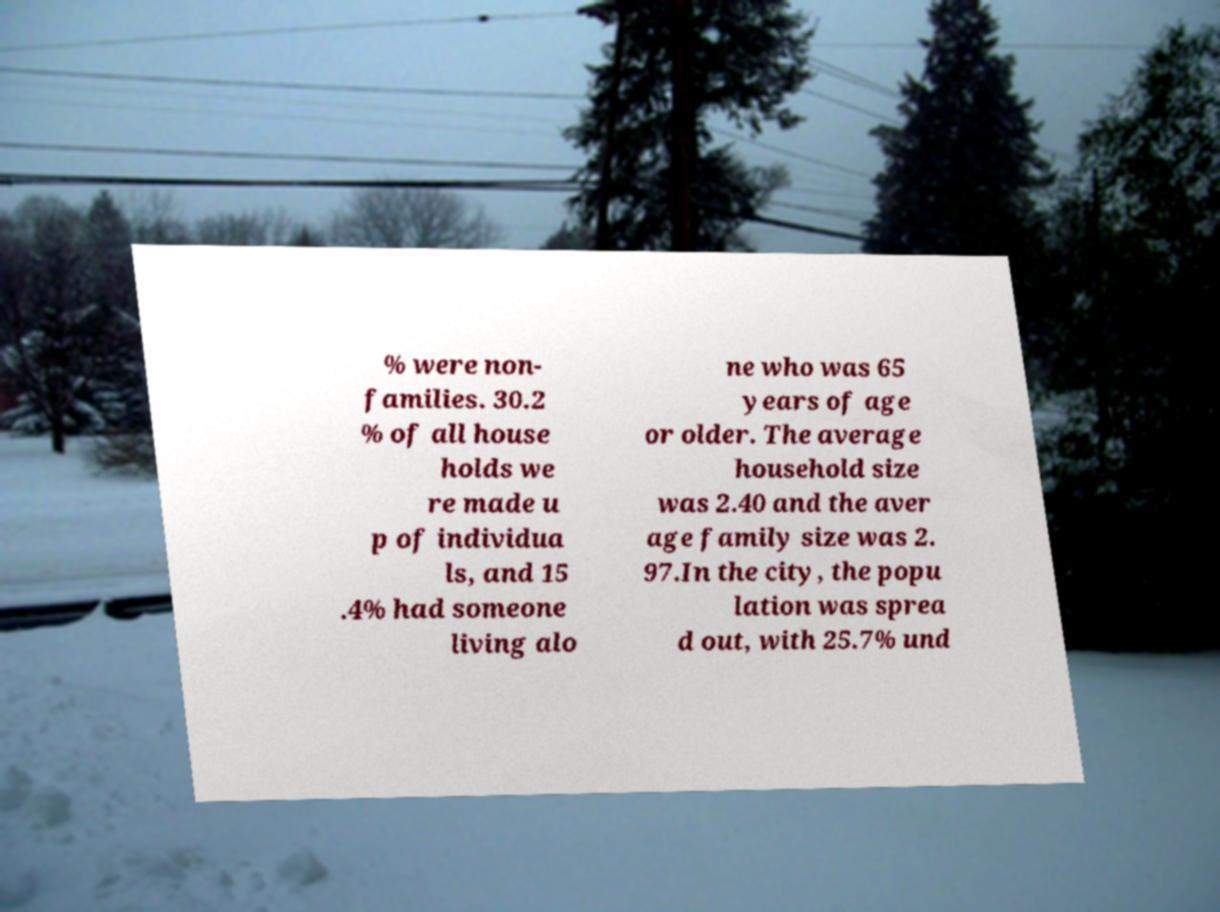Can you read and provide the text displayed in the image?This photo seems to have some interesting text. Can you extract and type it out for me? % were non- families. 30.2 % of all house holds we re made u p of individua ls, and 15 .4% had someone living alo ne who was 65 years of age or older. The average household size was 2.40 and the aver age family size was 2. 97.In the city, the popu lation was sprea d out, with 25.7% und 